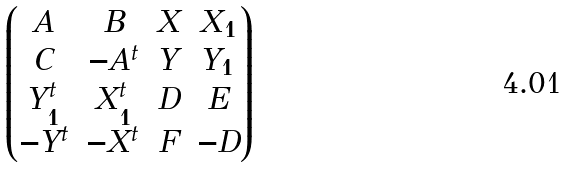Convert formula to latex. <formula><loc_0><loc_0><loc_500><loc_500>\begin{pmatrix} A & B & X & X _ { 1 } \\ C & - A ^ { t } & Y & Y _ { 1 } \\ Y _ { 1 } ^ { t } & X _ { 1 } ^ { t } & D & E \\ - Y ^ { t } & - X ^ { t } & F & - D \end{pmatrix}</formula> 